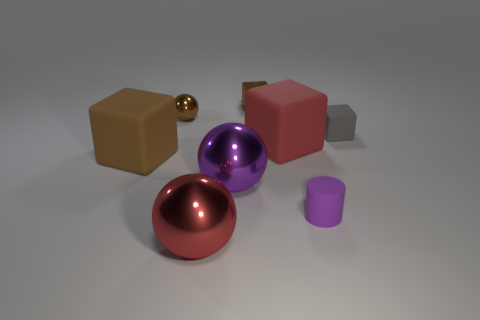Subtract all big brown matte cubes. How many cubes are left? 3 Subtract all purple spheres. How many spheres are left? 2 Add 1 tiny yellow shiny cubes. How many objects exist? 9 Subtract all cylinders. How many objects are left? 7 Subtract 4 cubes. How many cubes are left? 0 Subtract all red balls. Subtract all blue cylinders. How many balls are left? 2 Subtract all purple cylinders. How many red balls are left? 1 Subtract all small yellow matte things. Subtract all small shiny blocks. How many objects are left? 7 Add 5 small brown spheres. How many small brown spheres are left? 6 Add 5 large red rubber blocks. How many large red rubber blocks exist? 6 